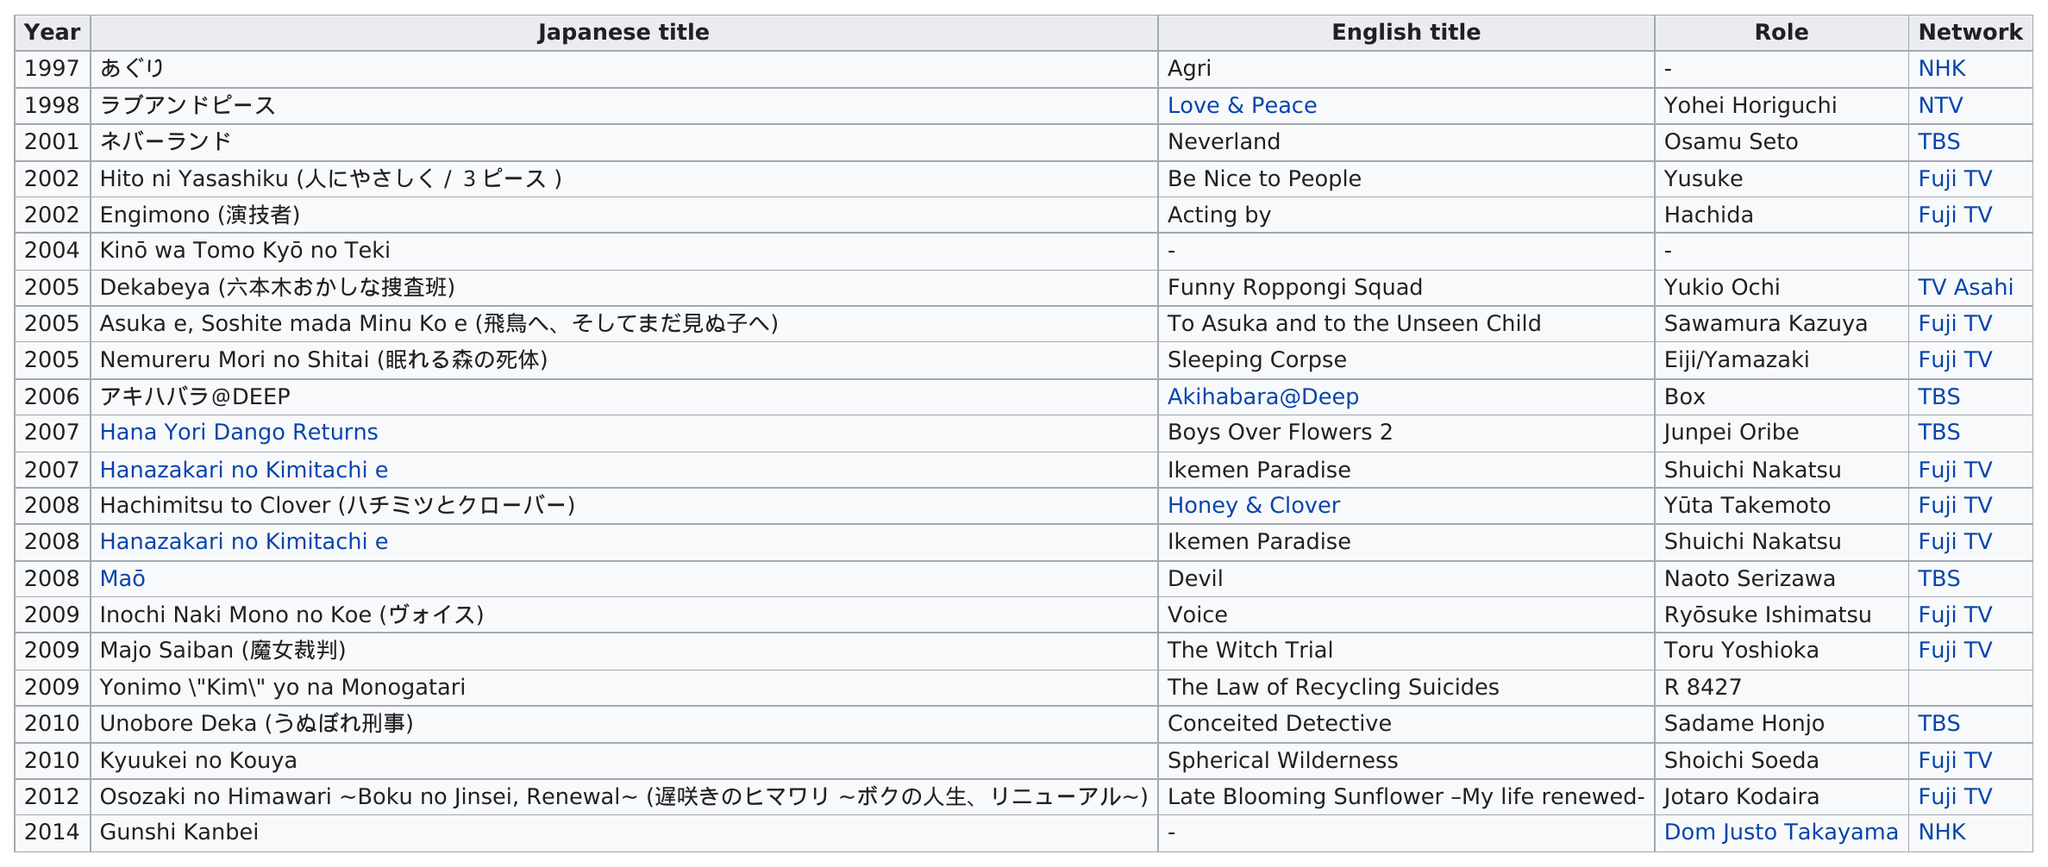Mention a couple of crucial points in this snapshot. What was the total role in the year 2008? It was 3. There were 6 more appearances on Fuji TV than on TBS. The years 2005, 2008, and 2009 were the years in which the highest number of Japanese titles were produced. In 2009, actor Ikuta Toma portrayed multiple roles in various productions. The first English title role to be performed was that of 'Agrippina,' which debuted in London in the year 1695. 